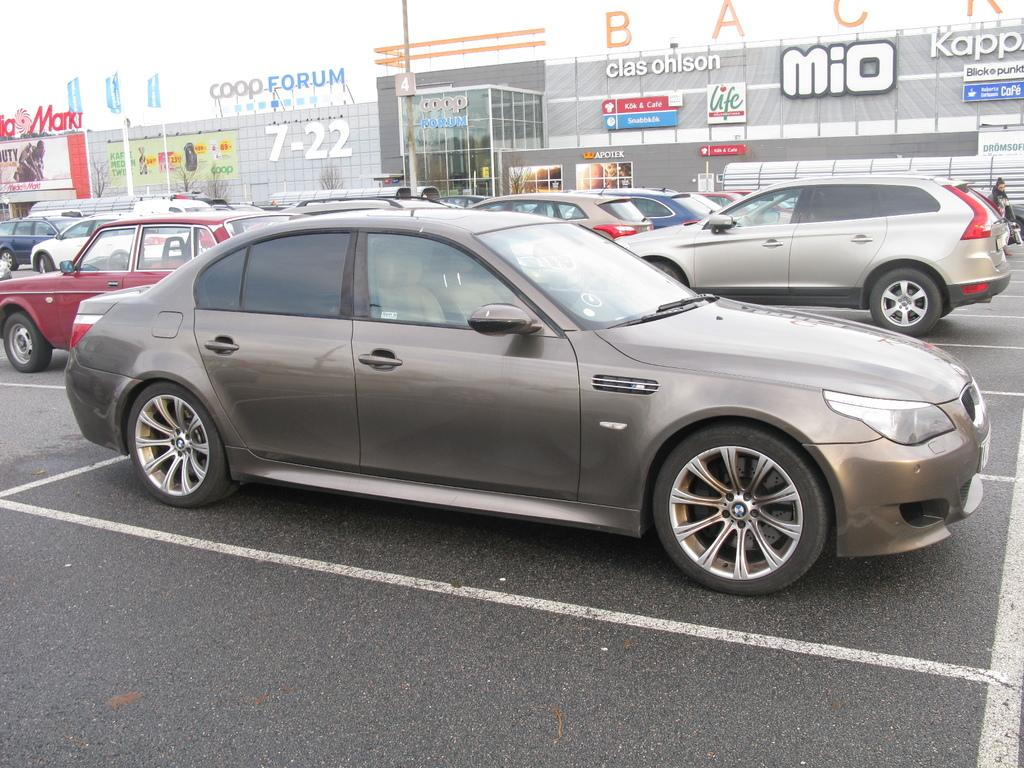What is the main subject of the image? The main subject of the image is a group of vehicles. Can you describe the person in the image? There is a person on the road in the image. What can be seen in the background of the image? In the background of the image, there are buildings, boards with text, flags, and poles. What type of comfort can be seen in the yard in the image? There is no yard present in the image, and therefore no comfort can be observed. 